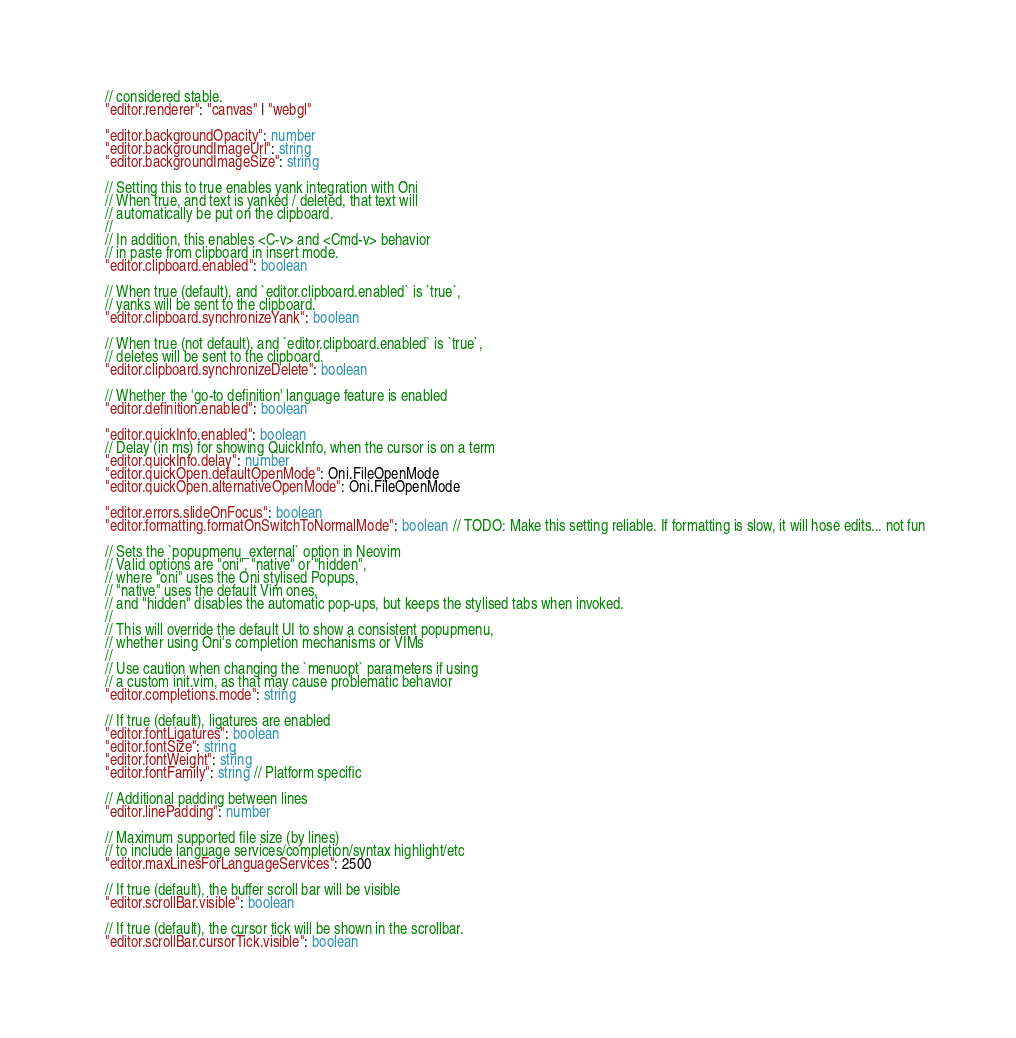<code> <loc_0><loc_0><loc_500><loc_500><_TypeScript_>    // considered stable.
    "editor.renderer": "canvas" | "webgl"

    "editor.backgroundOpacity": number
    "editor.backgroundImageUrl": string
    "editor.backgroundImageSize": string

    // Setting this to true enables yank integration with Oni
    // When true, and text is yanked / deleted, that text will
    // automatically be put on the clipboard.
    //
    // In addition, this enables <C-v> and <Cmd-v> behavior
    // in paste from clipboard in insert mode.
    "editor.clipboard.enabled": boolean

    // When true (default), and `editor.clipboard.enabled` is `true`,
    // yanks will be sent to the clipboard.
    "editor.clipboard.synchronizeYank": boolean

    // When true (not default), and `editor.clipboard.enabled` is `true`,
    // deletes will be sent to the clipboard.
    "editor.clipboard.synchronizeDelete": boolean

    // Whether the 'go-to definition' language feature is enabled
    "editor.definition.enabled": boolean

    "editor.quickInfo.enabled": boolean
    // Delay (in ms) for showing QuickInfo, when the cursor is on a term
    "editor.quickInfo.delay": number
    "editor.quickOpen.defaultOpenMode": Oni.FileOpenMode
    "editor.quickOpen.alternativeOpenMode": Oni.FileOpenMode

    "editor.errors.slideOnFocus": boolean
    "editor.formatting.formatOnSwitchToNormalMode": boolean // TODO: Make this setting reliable. If formatting is slow, it will hose edits... not fun

    // Sets the `popupmenu_external` option in Neovim
    // Valid options are "oni", "native" or "hidden",
    // where "oni" uses the Oni stylised Popups,
    // "native" uses the default Vim ones,
    // and "hidden" disables the automatic pop-ups, but keeps the stylised tabs when invoked.
    //
    // This will override the default UI to show a consistent popupmenu,
    // whether using Oni's completion mechanisms or VIMs
    //
    // Use caution when changing the `menuopt` parameters if using
    // a custom init.vim, as that may cause problematic behavior
    "editor.completions.mode": string

    // If true (default), ligatures are enabled
    "editor.fontLigatures": boolean
    "editor.fontSize": string
    "editor.fontWeight": string
    "editor.fontFamily": string // Platform specific

    // Additional padding between lines
    "editor.linePadding": number

    // Maximum supported file size (by lines)
    // to include language services/completion/syntax highlight/etc
    "editor.maxLinesForLanguageServices": 2500

    // If true (default), the buffer scroll bar will be visible
    "editor.scrollBar.visible": boolean

    // If true (default), the cursor tick will be shown in the scrollbar.
    "editor.scrollBar.cursorTick.visible": boolean
</code> 